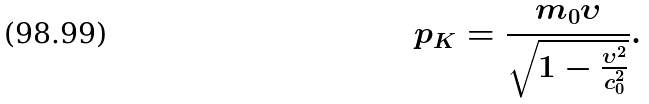<formula> <loc_0><loc_0><loc_500><loc_500>p _ { K } = \frac { m _ { 0 } \upsilon } { \sqrt { 1 - \frac { \upsilon ^ { 2 } } { c _ { 0 } ^ { 2 } } } } .</formula> 